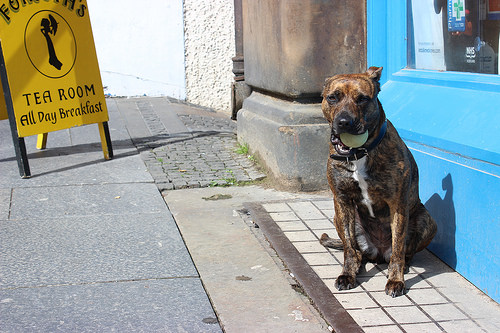<image>
Is the dog above the tile? No. The dog is not positioned above the tile. The vertical arrangement shows a different relationship. 